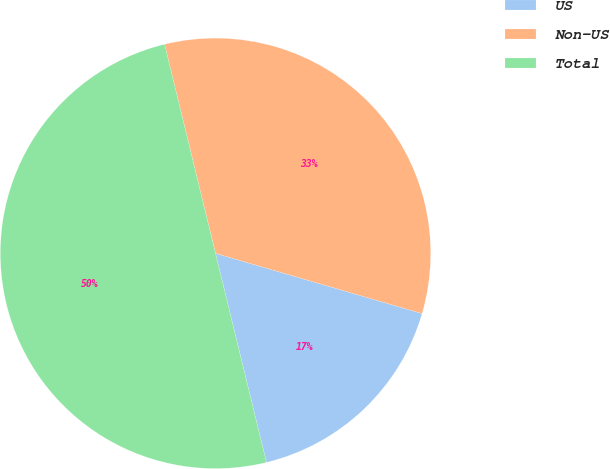<chart> <loc_0><loc_0><loc_500><loc_500><pie_chart><fcel>US<fcel>Non-US<fcel>Total<nl><fcel>16.68%<fcel>33.32%<fcel>50.0%<nl></chart> 